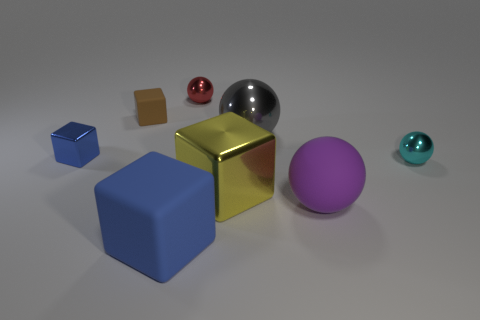What color is the sphere that is to the right of the big purple matte object?
Provide a short and direct response. Cyan. How many other things are there of the same color as the large rubber block?
Provide a short and direct response. 1. Does the metal block right of the red shiny sphere have the same size as the big blue cube?
Give a very brief answer. Yes. There is a large gray shiny ball; how many small shiny cubes are in front of it?
Give a very brief answer. 1. Is there a cube of the same size as the purple object?
Your response must be concise. Yes. Is the color of the large rubber block the same as the small shiny block?
Give a very brief answer. Yes. The tiny matte thing that is behind the sphere that is in front of the big yellow metallic thing is what color?
Provide a succinct answer. Brown. What number of things are both in front of the small red metal thing and to the left of the big gray metal object?
Provide a short and direct response. 4. How many other big objects have the same shape as the gray shiny object?
Your answer should be very brief. 1. Does the big blue block have the same material as the large yellow thing?
Your response must be concise. No. 